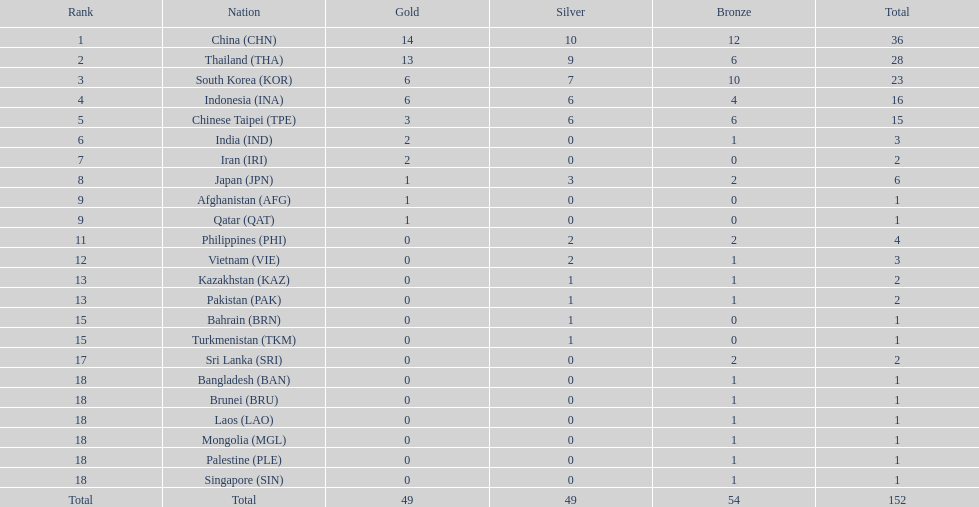How many countries obtained over 5 gold medals? 4. 